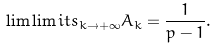<formula> <loc_0><loc_0><loc_500><loc_500>\lim \lim i t s _ { k \rightarrow + \infty } A _ { k } = \frac { 1 } { p - 1 } .</formula> 